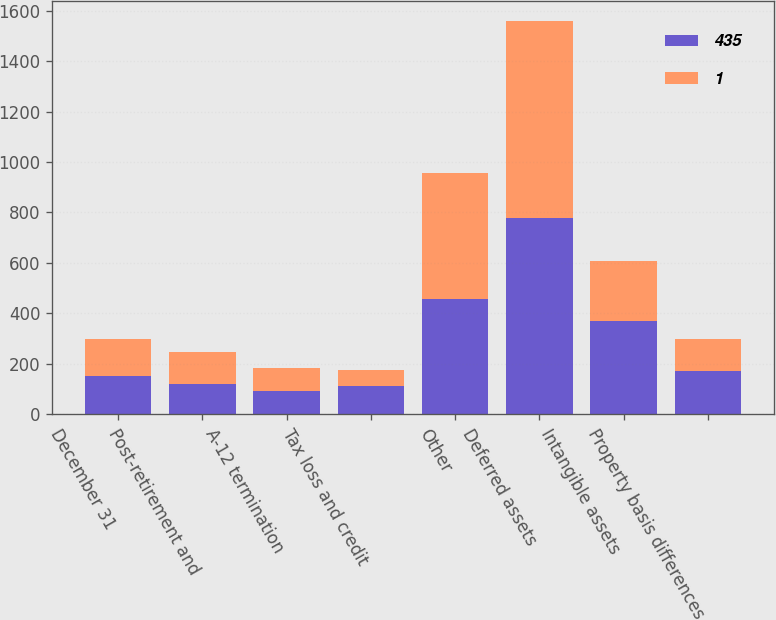Convert chart. <chart><loc_0><loc_0><loc_500><loc_500><stacked_bar_chart><ecel><fcel>December 31<fcel>Post-retirement and<fcel>A-12 termination<fcel>Tax loss and credit<fcel>Other<fcel>Deferred assets<fcel>Intangible assets<fcel>Property basis differences<nl><fcel>435<fcel>149.5<fcel>119<fcel>91<fcel>111<fcel>455<fcel>776<fcel>368<fcel>172<nl><fcel>1<fcel>149.5<fcel>127<fcel>93<fcel>63<fcel>501<fcel>784<fcel>237<fcel>127<nl></chart> 